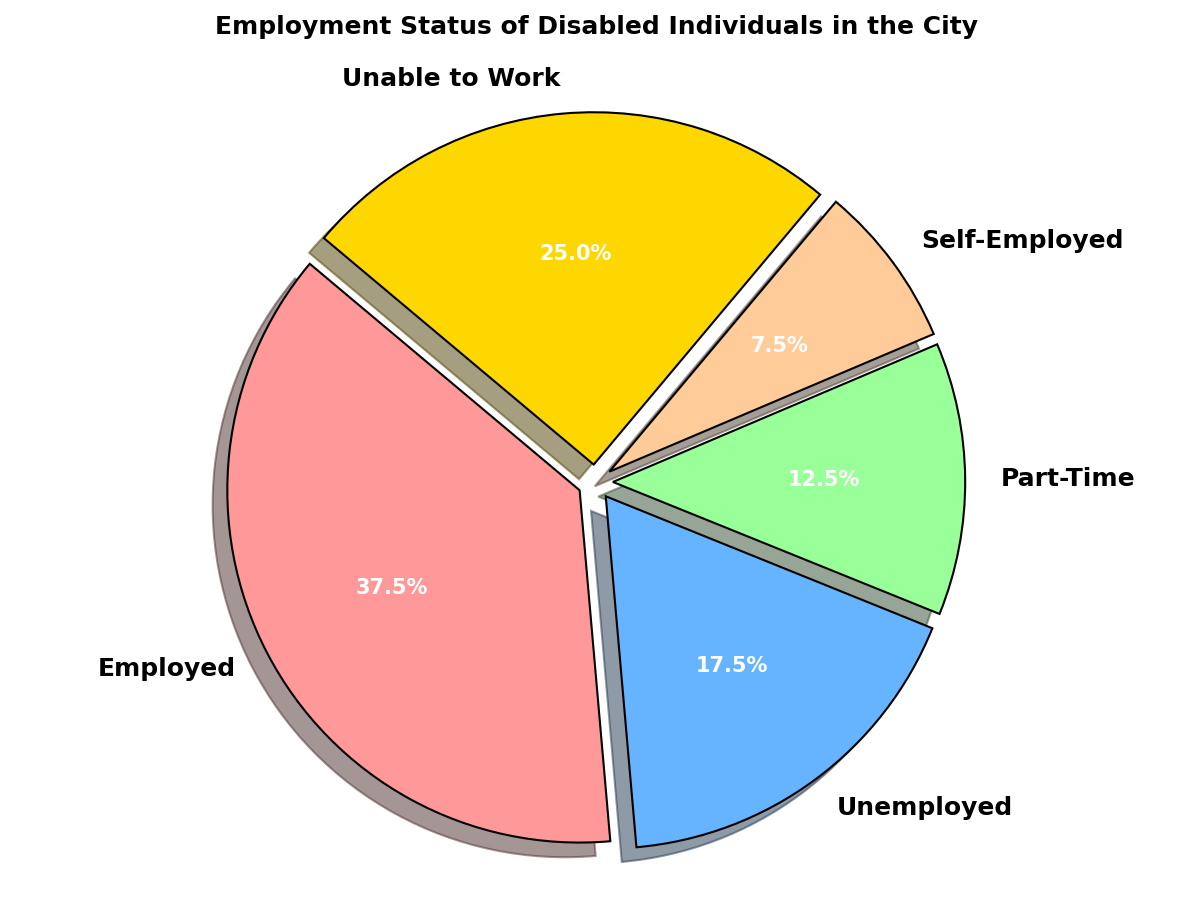What percentage of disabled individuals are employed? The pie chart shows labeled segments for each employment status. Find the percentage label for 'Employed'.
Answer: 42.9% What is the combined percentage of disabled individuals who are either unemployed or unable to work? Sum the percentages for 'Unemployed' and 'Unable to Work' from the pie chart. The 'Unemployed' percentage is 20.0%, and the 'Unable to Work' percentage is 28.6%. Adding them gives 20.0% + 28.6% = 48.6%.
Answer: 48.6% Which employment status has the smallest representation? The smallest wedge in the pie chart corresponds to 'Self-Employed'.
Answer: Self-Employed Are there more part-time workers or self-employed individuals? Compare the percentage labels for 'Part-Time' and 'Self-Employed'. 'Part-Time' has a higher percentage than 'Self-Employed' based on the pie chart.
Answer: Part-Time What is the total percentage of disabled individuals who are either employed or part-time workers? Sum the percentages for 'Employed' and 'Part-Time'. The pie chart shows 42.9% for 'Employed' and 14.3% for 'Part-Time'. Adding them gives 42.9% + 14.3% = 57.2%.
Answer: 57.2% Which color represents the segment for individuals unable to work? The color associated with 'Unable to Work' in the pie chart is yellow.
Answer: Yellow How many employment statuses are considered in this chart? Count the distinct labels in the pie chart: Employed, Unemployed, Part-Time, Self-Employed, Unable to Work.
Answer: 5 Which segment accounts for more individuals: unemployed or employed? Compare the percentages for 'Unemployed' and 'Employed'. 'Employed' has a higher percentage (42.9%) compared to 'Unemployed' (20.0%).
Answer: Employed What fraction of disabled individuals are part-time workers? The percentage for 'Part-Time' is 14.3%. To find the fraction, convert the percentage to a fraction: 14.3% is approximately 14.3/100, which simplifies to 1/7 when rounded.
Answer: 1/7 What visual cue is used to differentiate segments in the pie chart? Each segment in the pie chart has a unique color and a slight separation (explode effect) to differentiate it from the other segments.
Answer: Unique color and explosion effect 